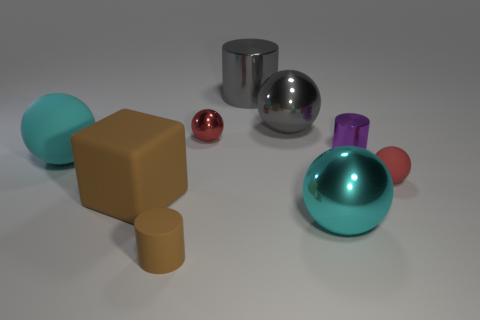There is a red rubber thing that is the same shape as the cyan matte object; what size is it?
Make the answer very short. Small. What is the color of the small cylinder behind the large metal sphere that is in front of the purple thing?
Keep it short and to the point. Purple. What number of balls are either small brown objects or small red metallic objects?
Your answer should be compact. 1. There is a large sphere in front of the small sphere on the right side of the purple metallic cylinder; how many big cylinders are to the right of it?
Offer a very short reply. 0. There is a ball that is the same color as the large metallic cylinder; what size is it?
Offer a very short reply. Large. Is there a red ball made of the same material as the big cylinder?
Offer a very short reply. Yes. Does the tiny brown thing have the same material as the block?
Your answer should be compact. Yes. What number of large metallic spheres are behind the tiny sphere right of the purple cylinder?
Make the answer very short. 1. What number of red things are either rubber cylinders or shiny objects?
Keep it short and to the point. 1. What is the shape of the cyan shiny object to the right of the large matte object that is to the right of the large cyan ball that is behind the tiny red matte sphere?
Your response must be concise. Sphere. 